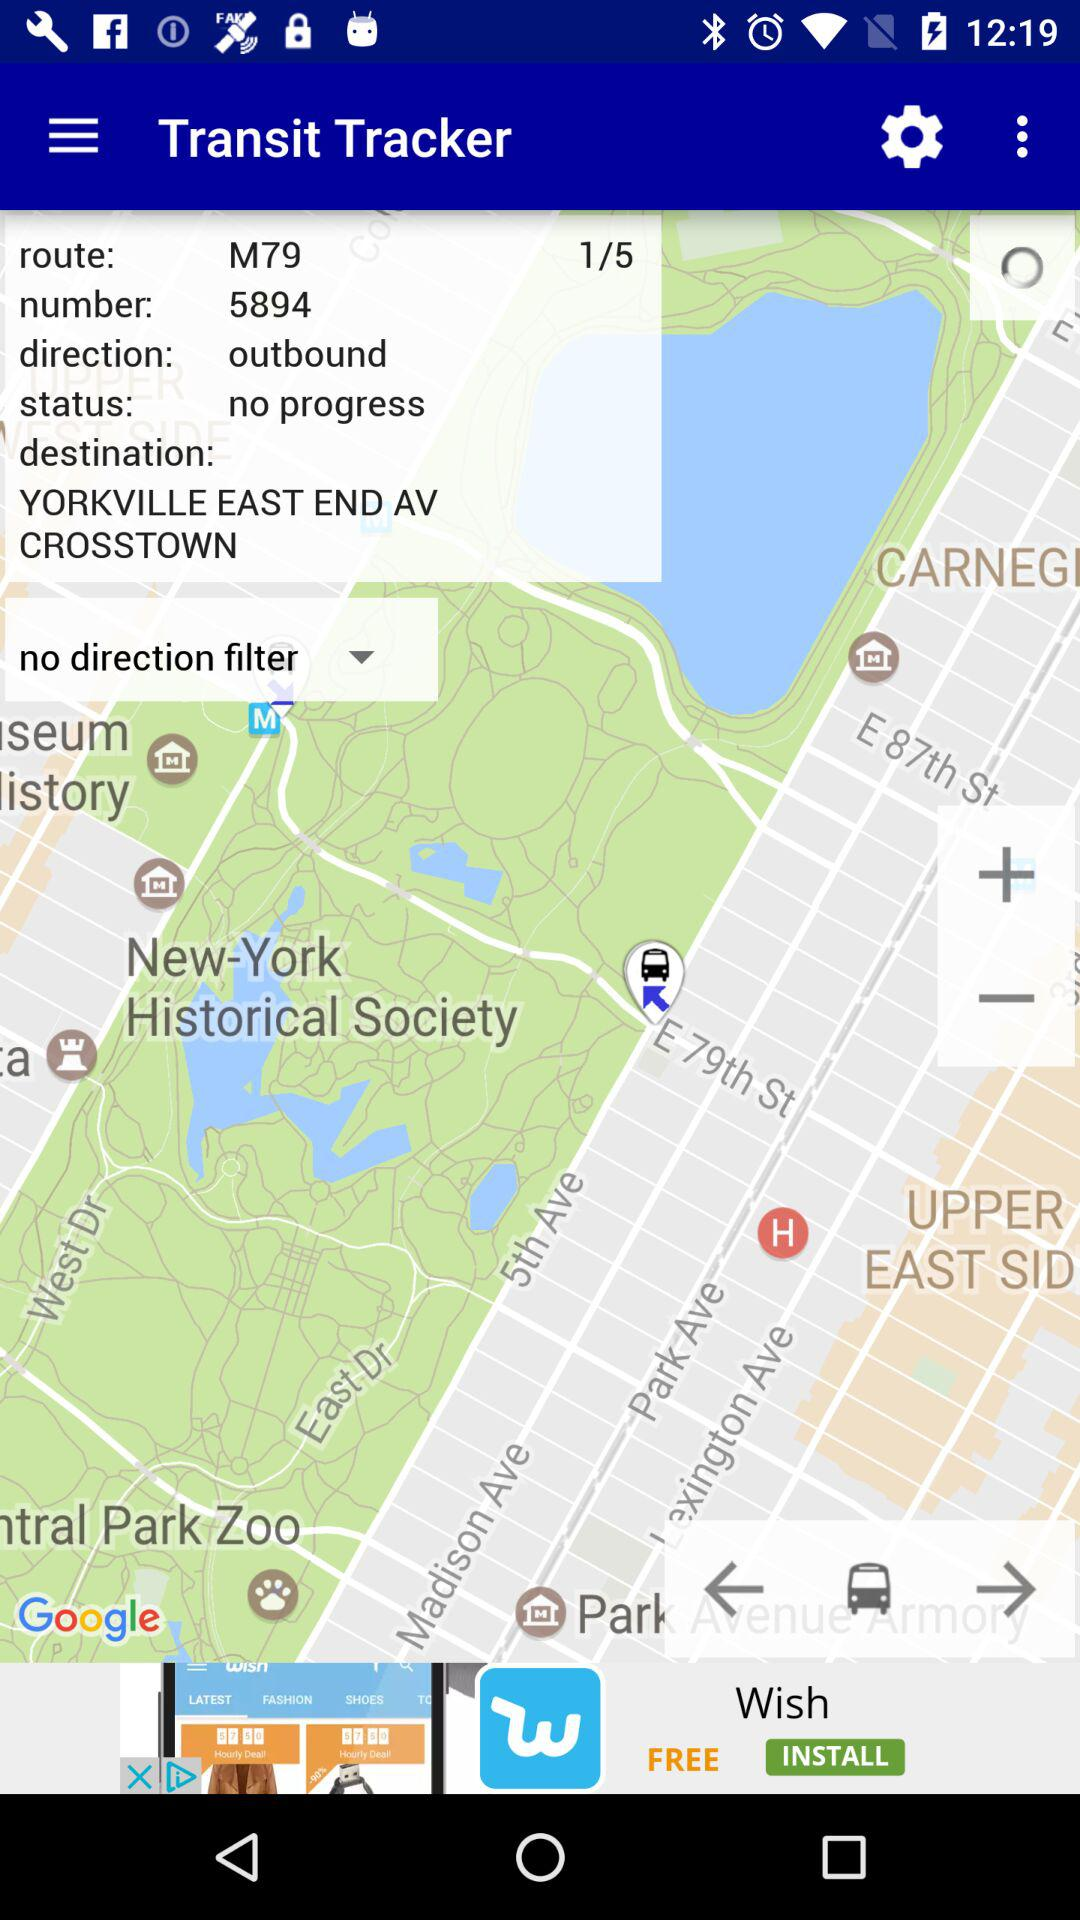How many routes in total are there in the "Transit Tracker"? There are 5 routes in total. 